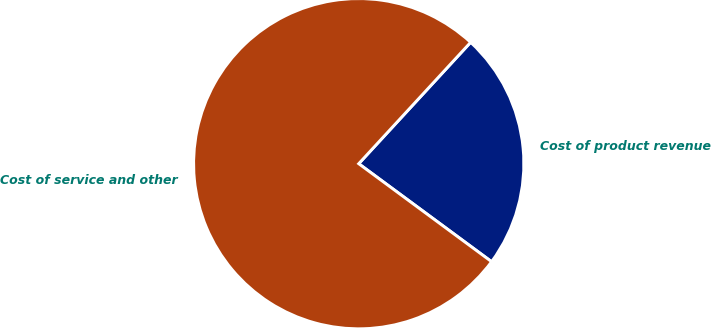Convert chart to OTSL. <chart><loc_0><loc_0><loc_500><loc_500><pie_chart><fcel>Cost of product revenue<fcel>Cost of service and other<nl><fcel>23.26%<fcel>76.74%<nl></chart> 